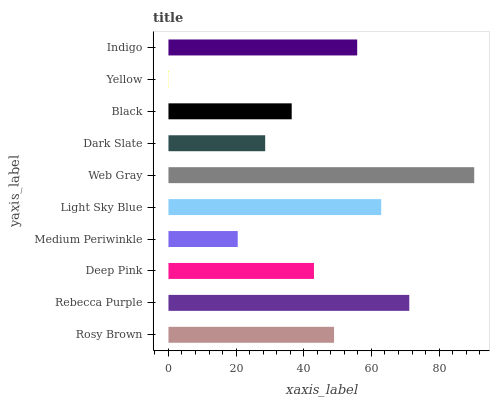Is Yellow the minimum?
Answer yes or no. Yes. Is Web Gray the maximum?
Answer yes or no. Yes. Is Rebecca Purple the minimum?
Answer yes or no. No. Is Rebecca Purple the maximum?
Answer yes or no. No. Is Rebecca Purple greater than Rosy Brown?
Answer yes or no. Yes. Is Rosy Brown less than Rebecca Purple?
Answer yes or no. Yes. Is Rosy Brown greater than Rebecca Purple?
Answer yes or no. No. Is Rebecca Purple less than Rosy Brown?
Answer yes or no. No. Is Rosy Brown the high median?
Answer yes or no. Yes. Is Deep Pink the low median?
Answer yes or no. Yes. Is Light Sky Blue the high median?
Answer yes or no. No. Is Black the low median?
Answer yes or no. No. 